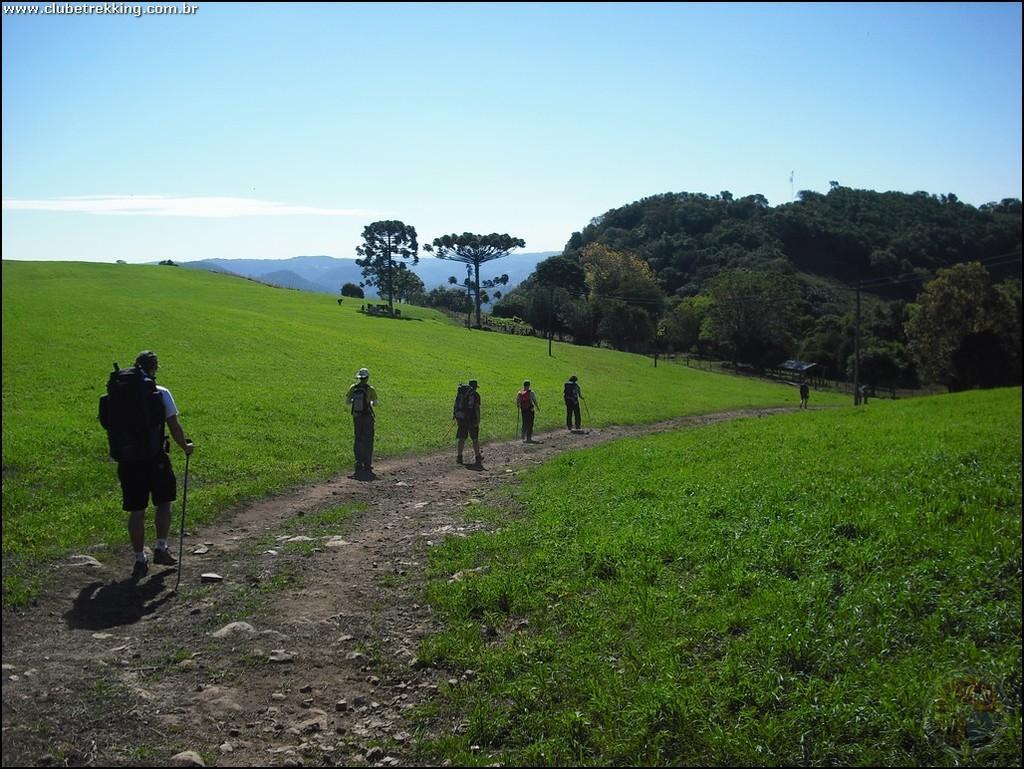Describe this image in one or two sentences. As we can see in the image there are few people here and there wearing bags and walking. There are trees, hill and grass. On the top there is sky. 